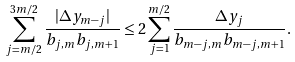<formula> <loc_0><loc_0><loc_500><loc_500>\sum _ { j = m / 2 } ^ { 3 m / 2 } \frac { | \Delta y _ { m - j } | } { b _ { j , m } b _ { j , m + 1 } } \leq 2 \sum _ { j = 1 } ^ { m / 2 } \frac { \Delta y _ { j } } { b _ { m - j , m } b _ { m - j , m + 1 } } .</formula> 